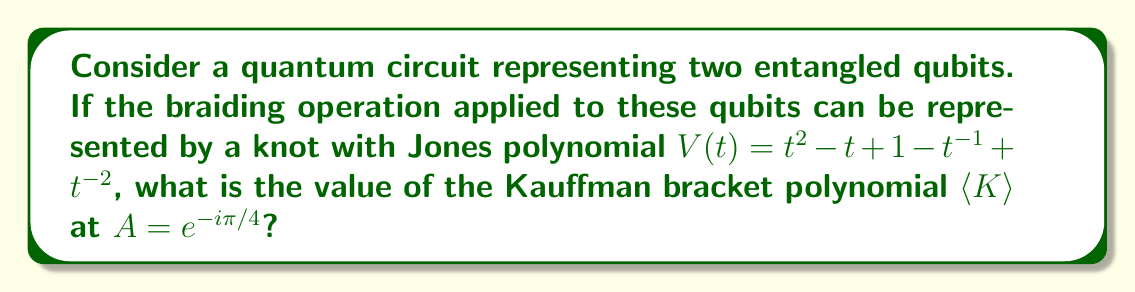Can you answer this question? To solve this problem, we'll follow these steps:

1) Recall the relationship between the Jones polynomial $V(t)$ and the Kauffman bracket polynomial $\langle K \rangle$:

   $$V(t) = (-A^3)^{-w(K)} \langle K \rangle |_{A = t^{-1/4}}$$

   where $w(K)$ is the writhe of the knot.

2) We're given $V(t) = t^2 - t + 1 - t^{-1} + t^{-2}$. This is the Jones polynomial for the figure-eight knot, which has a writhe of 0.

3) Since $w(K) = 0$, our equation simplifies to:

   $$V(t) = \langle K \rangle |_{A = t^{-1/4}}$$

4) We need to find $\langle K \rangle$ at $A = e^{-i\pi/4}$. This means we need to solve for $t$ in:

   $$e^{-i\pi/4} = t^{-1/4}$$

5) Solving this:
   $$t = e^{i\pi} = -1$$

6) Now, we can evaluate $V(-1)$:

   $$V(-1) = (-1)^2 - (-1) + 1 - (-1)^{-1} + (-1)^{-2} = 1 + 1 + 1 + 1 + 1 = 5$$

7) Therefore, $\langle K \rangle$ at $A = e^{-i\pi/4}$ is equal to 5.

This result indicates that the quantum state represented by this knot has a specific topological property, which could be significant in the context of topological quantum computing.
Answer: 5 